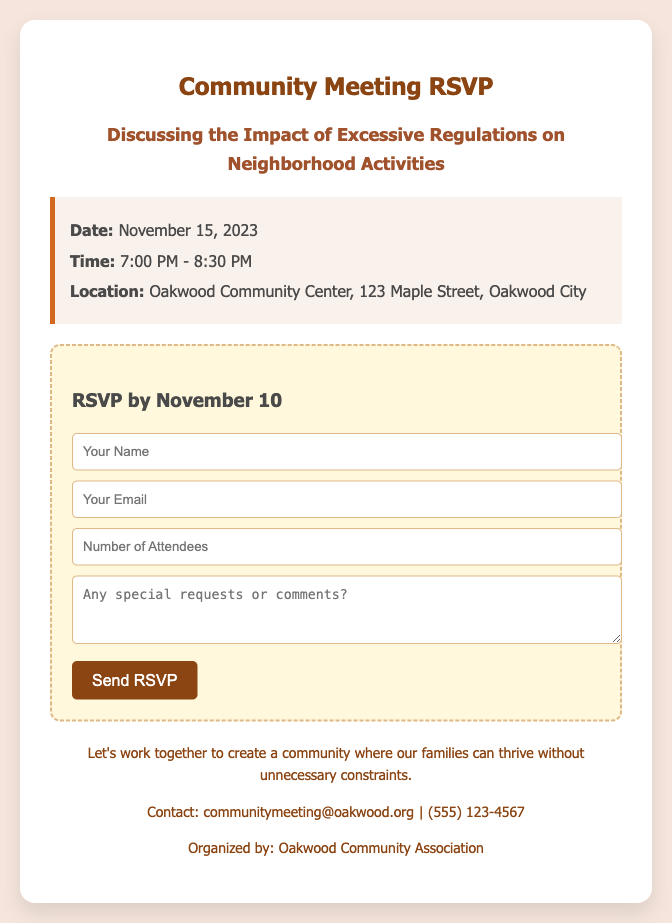What is the date of the community meeting? The date of the community meeting is specifically mentioned in the document as November 15, 2023.
Answer: November 15, 2023 What time does the meeting start? The start time of the meeting is indicated as 7:00 PM.
Answer: 7:00 PM Where is the community meeting being held? The location of the meeting is clearly stated as Oakwood Community Center, 123 Maple Street, Oakwood City.
Answer: Oakwood Community Center, 123 Maple Street, Oakwood City By what date do you need to RSVP? The document specifies the RSVP deadline as November 10.
Answer: November 10 What is the main topic of discussion for the community meeting? The main topic of discussion is mentioned directly as the impact of excessive regulations on neighborhood activities.
Answer: Impact of excessive regulations on neighborhood activities If I want to contact the organizers, which email should I use? The contact email provided for the organizers is communitymeeting@oakwood.org, which is explicitly mentioned in the footer of the document.
Answer: communitymeeting@oakwood.org What organization is hosting the community meeting? The document notes that the meeting is organized by the Oakwood Community Association.
Answer: Oakwood Community Association How long is the community meeting scheduled to last? The document indicates that the meeting is scheduled to last from 7:00 PM to 8:30 PM, which totals 1.5 hours.
Answer: 1.5 hours 